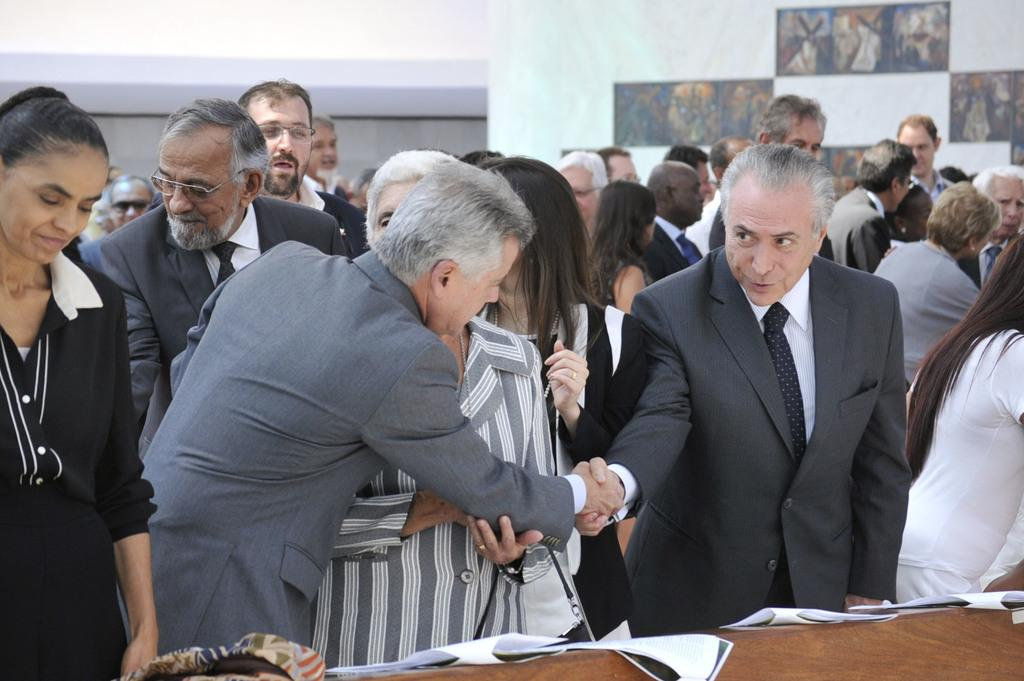What can be seen in the image? There is a group of people in the image. What is on the table in the image? There are papers on a table in the image. What is visible in the background of the image? There is a wall in the background of the image. What is hanging on the wall in the background of the image? There are frames on the wall in the background of the image. What type of pie is being served to the group of people in the image? There is no pie present in the image; it only shows a group of people, papers on a table, and frames on the wall in the background. 